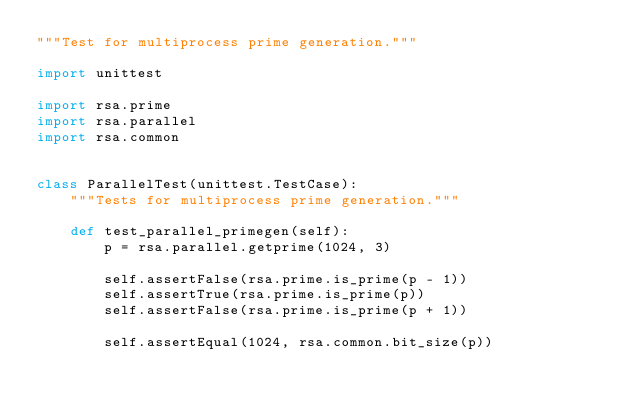Convert code to text. <code><loc_0><loc_0><loc_500><loc_500><_Python_>"""Test for multiprocess prime generation."""

import unittest

import rsa.prime
import rsa.parallel
import rsa.common


class ParallelTest(unittest.TestCase):
    """Tests for multiprocess prime generation."""

    def test_parallel_primegen(self):
        p = rsa.parallel.getprime(1024, 3)

        self.assertFalse(rsa.prime.is_prime(p - 1))
        self.assertTrue(rsa.prime.is_prime(p))
        self.assertFalse(rsa.prime.is_prime(p + 1))

        self.assertEqual(1024, rsa.common.bit_size(p))
</code> 